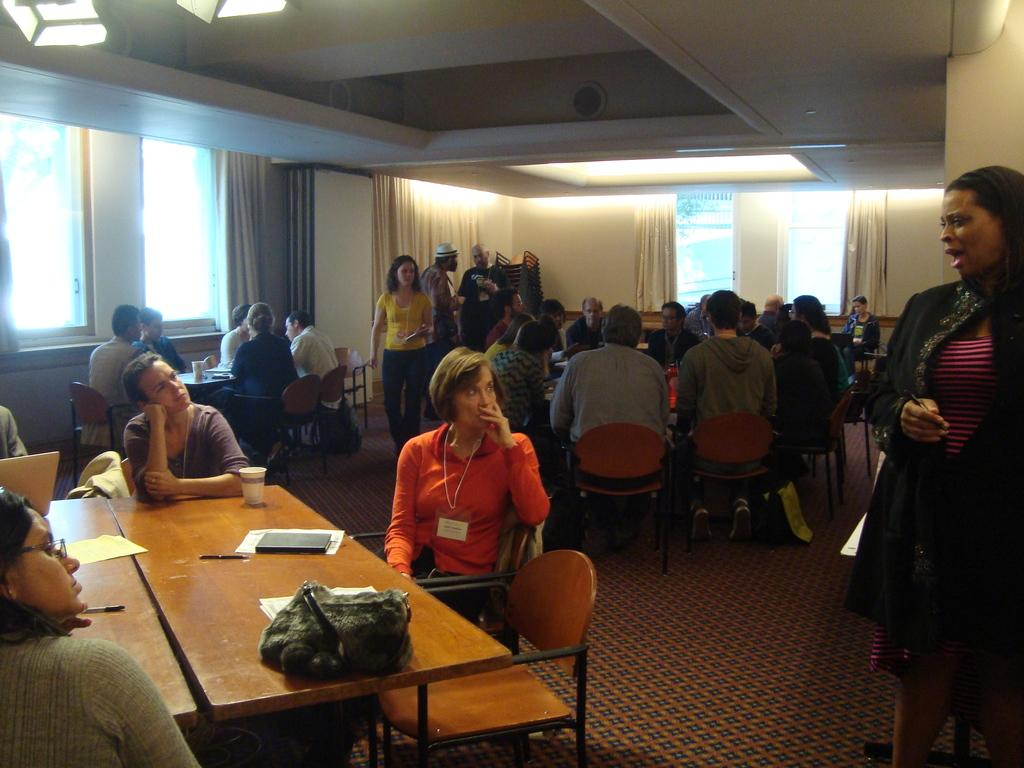How many people are in the image? There are many people in the image. What are the people doing in the image? The people are sitting on chairs. What objects are in front of the chairs? There are tables in front of the chairs. What type of map can be seen on the tables in the image? There is no map present on the tables in the image. Are there any jellyfish swimming in the air above the people in the image? There are no jellyfish present in the image. 